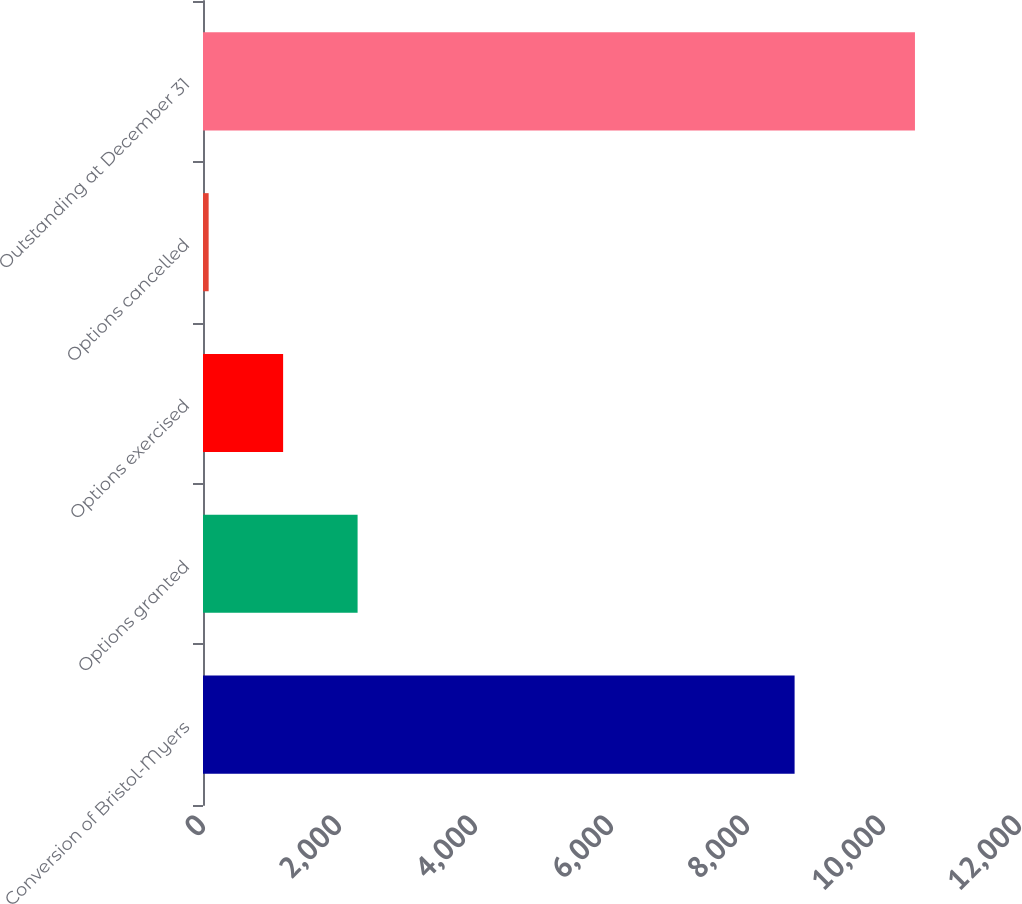Convert chart. <chart><loc_0><loc_0><loc_500><loc_500><bar_chart><fcel>Conversion of Bristol-Myers<fcel>Options granted<fcel>Options exercised<fcel>Options cancelled<fcel>Outstanding at December 31<nl><fcel>8700<fcel>2273.4<fcel>1178.2<fcel>83<fcel>10470<nl></chart> 